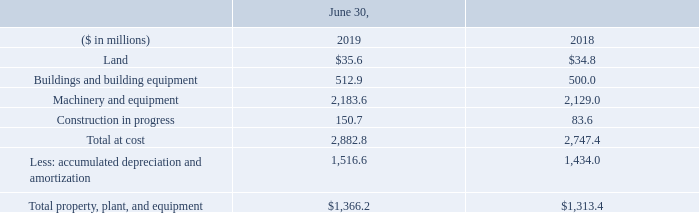7. Property, Plant and Equipment
Property, plant and equipment consisted of the following components at June 30, 2019 and 2018:
What was the amount of Land in 2019? $35.6. What was the amount of  Buildings and building equipment in 2018? 500.0. In which years was Property, Plant and Equipment calculated? 2019, 2018. In which year was the amount of Land larger? 35.6>34.8
Answer: 2019. What was the change in Buildings and building equipment in 2019 from 2018?
Answer scale should be: million. 512.9-500.0
Answer: 12.9. What was the percentage change in Buildings and building equipment in 2019 from 2018?
Answer scale should be: percent. (512.9-500.0)/500.0
Answer: 2.58. 